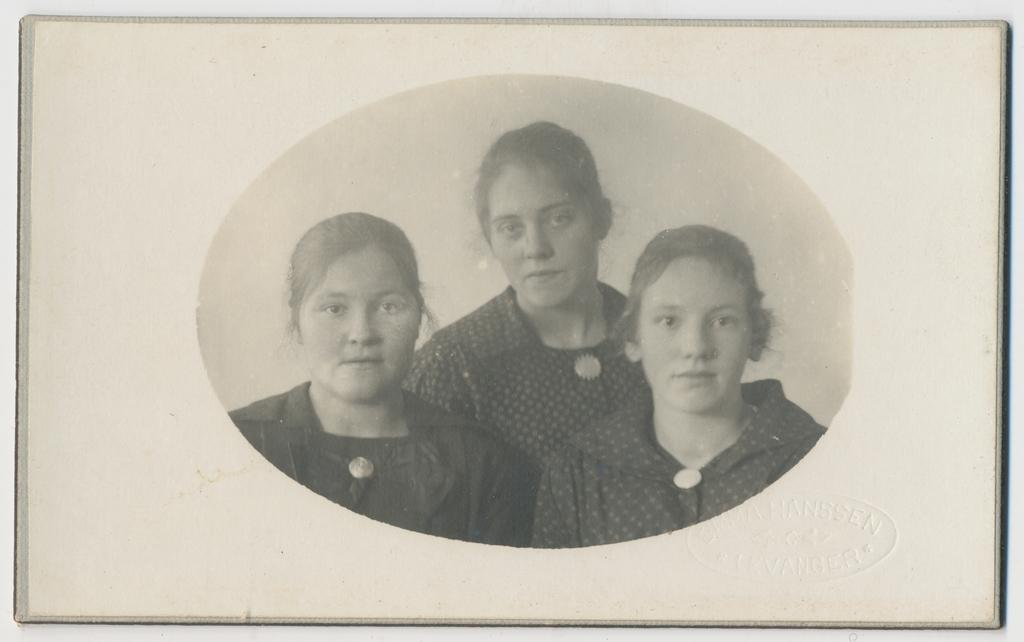How many people are in the image? There are three girls in the middle of the image. What is the color scheme of the image? The image is in black and white color. Is the image contained within any specific object? The image appears to be in a photo frame. What type of quiver can be seen in the image? There is no quiver present in the image. Is there a boy visible in the image? No, the image only features three girls. Can you see a sink in the image? No, there is no sink visible in the image. 